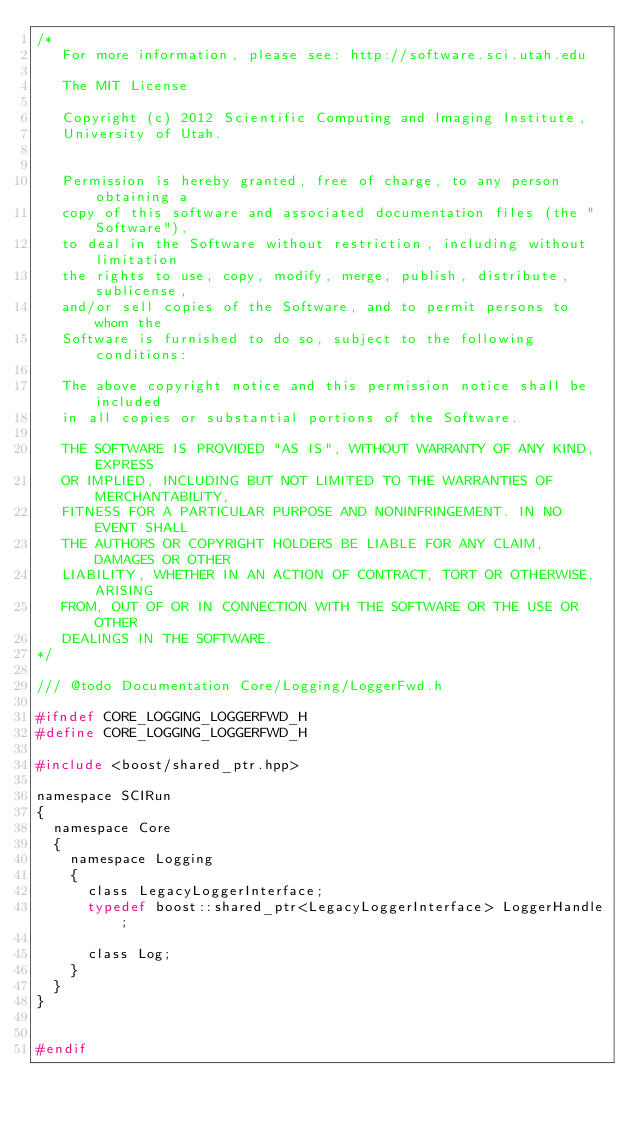<code> <loc_0><loc_0><loc_500><loc_500><_C_>/*
   For more information, please see: http://software.sci.utah.edu

   The MIT License

   Copyright (c) 2012 Scientific Computing and Imaging Institute,
   University of Utah.

   
   Permission is hereby granted, free of charge, to any person obtaining a
   copy of this software and associated documentation files (the "Software"),
   to deal in the Software without restriction, including without limitation
   the rights to use, copy, modify, merge, publish, distribute, sublicense,
   and/or sell copies of the Software, and to permit persons to whom the
   Software is furnished to do so, subject to the following conditions:

   The above copyright notice and this permission notice shall be included
   in all copies or substantial portions of the Software.

   THE SOFTWARE IS PROVIDED "AS IS", WITHOUT WARRANTY OF ANY KIND, EXPRESS
   OR IMPLIED, INCLUDING BUT NOT LIMITED TO THE WARRANTIES OF MERCHANTABILITY,
   FITNESS FOR A PARTICULAR PURPOSE AND NONINFRINGEMENT. IN NO EVENT SHALL
   THE AUTHORS OR COPYRIGHT HOLDERS BE LIABLE FOR ANY CLAIM, DAMAGES OR OTHER
   LIABILITY, WHETHER IN AN ACTION OF CONTRACT, TORT OR OTHERWISE, ARISING
   FROM, OUT OF OR IN CONNECTION WITH THE SOFTWARE OR THE USE OR OTHER
   DEALINGS IN THE SOFTWARE.
*/

/// @todo Documentation Core/Logging/LoggerFwd.h

#ifndef CORE_LOGGING_LOGGERFWD_H
#define CORE_LOGGING_LOGGERFWD_H 

#include <boost/shared_ptr.hpp>

namespace SCIRun 
{
  namespace Core
  {
    namespace Logging
    {
      class LegacyLoggerInterface;
      typedef boost::shared_ptr<LegacyLoggerInterface> LoggerHandle;

      class Log;
    }
  }
}


#endif
</code> 